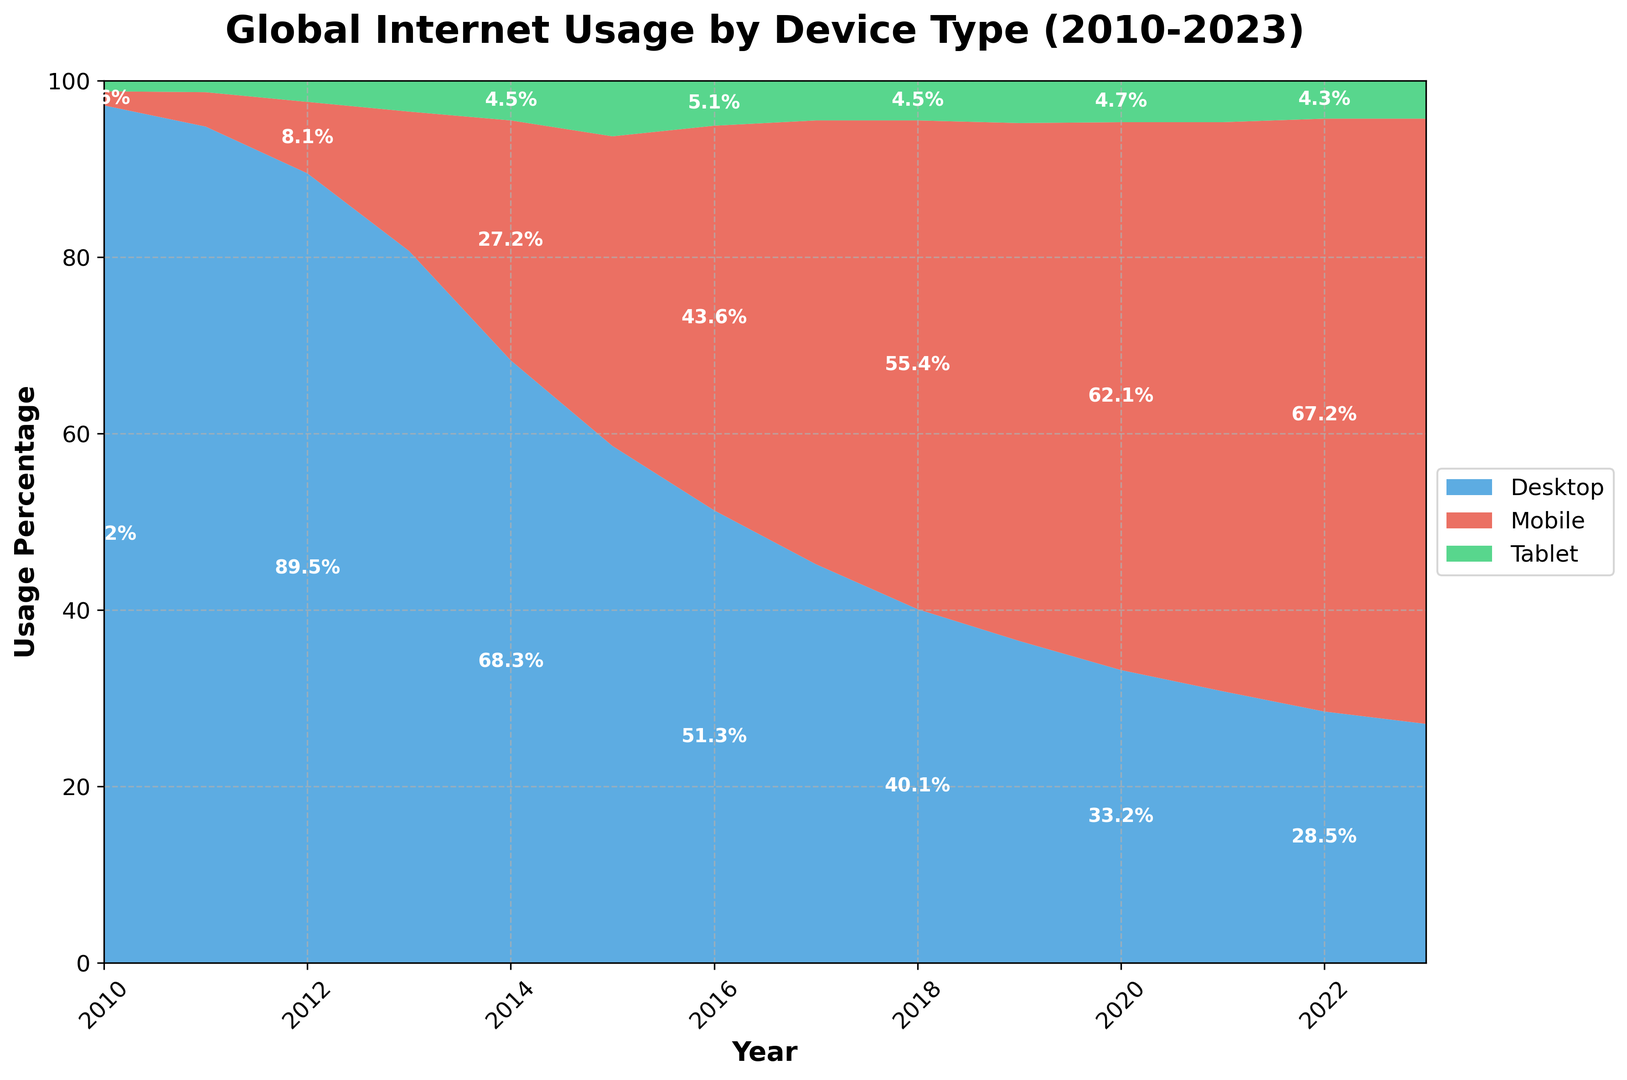Which device type had the highest usage percentage in 2010? Look at the heights of the areas in the stacked area chart for 2010. The blue area, representing Desktop, had the highest usage percentage.
Answer: Desktop How did the usage of mobile devices change from 2010 to 2023? Observe the red area representing Mobile from 2010 to 2023. It starts very low in 2010 and increases steadily to become the majority in 2023.
Answer: Increased steadily During which year did Desktop usage drop below 50%? Look at the blue area and find the year where it first dips below the halfway mark vertically, which is around 2016.
Answer: 2016 What is the trend of tablet usage from 2010 to 2023? Observe the green area representing Tablet. It increases slightly until around 2015 and then remains relatively stable.
Answer: Increases then stabilizes In 2020, how do the usage percentages of Desktop and Mobile compare? Check the heights of the blue (Desktop) and red (Mobile) areas in 2020. Mobile is significantly higher than Desktop.
Answer: Mobile is higher than Desktop What's the total usage percentage of all devices combined in 2015? Sum the heights of blue (Desktop), red (Mobile), and green (Tablet) areas in 2015. They should sum up to 100%, as the areas together represent the total of all devices.
Answer: 100% Which device type shows the most significant decrease from 2010 to 2023? Compare the heights of blue (Desktop), red (Mobile), and green (Tablet) areas between 2010 and 2023. The blue area shows the steepest decline.
Answer: Desktop What happens to mobile and desktop usage from 2016 to 2020? From 2016 to 2020, the red area representing Mobile increases, while the blue area representing Desktop decreases.
Answer: Mobile increases, Desktop decreases In which year was the combined usage of mobile and tablet devices nearly equal to desktop usage? Identify the year where the combined heights of red (Mobile) and green (Tablet) areas equal the height of the blue (Desktop) area. This is around 2015.
Answer: 2015 How does the tablet usage in 2023 compare to its usage in 2010? Compare the green area representing Tablet at the start (2010) and the end (2023) of the period. It remains nearly the same with slight variations.
Answer: Nearly the same 